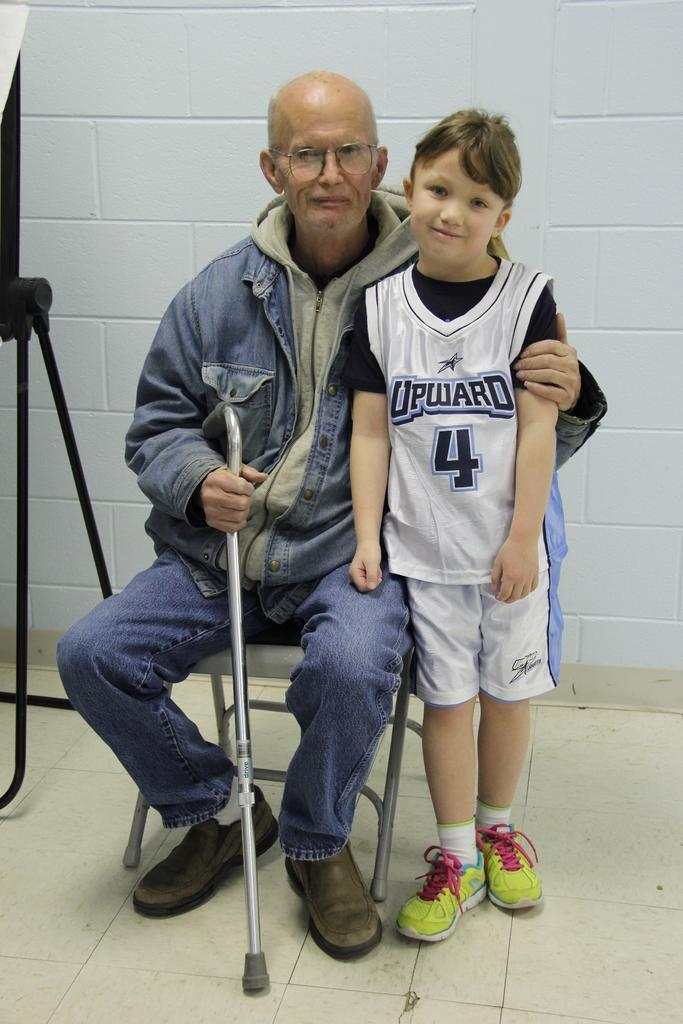Provide a one-sentence caption for the provided image. An older man with a cane sits next to a young child wearing an Upward sports jersey. 